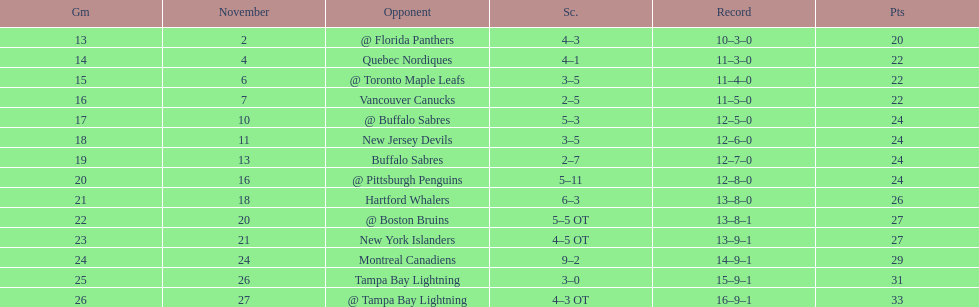Were the new jersey devils in last place according to the chart? No. 